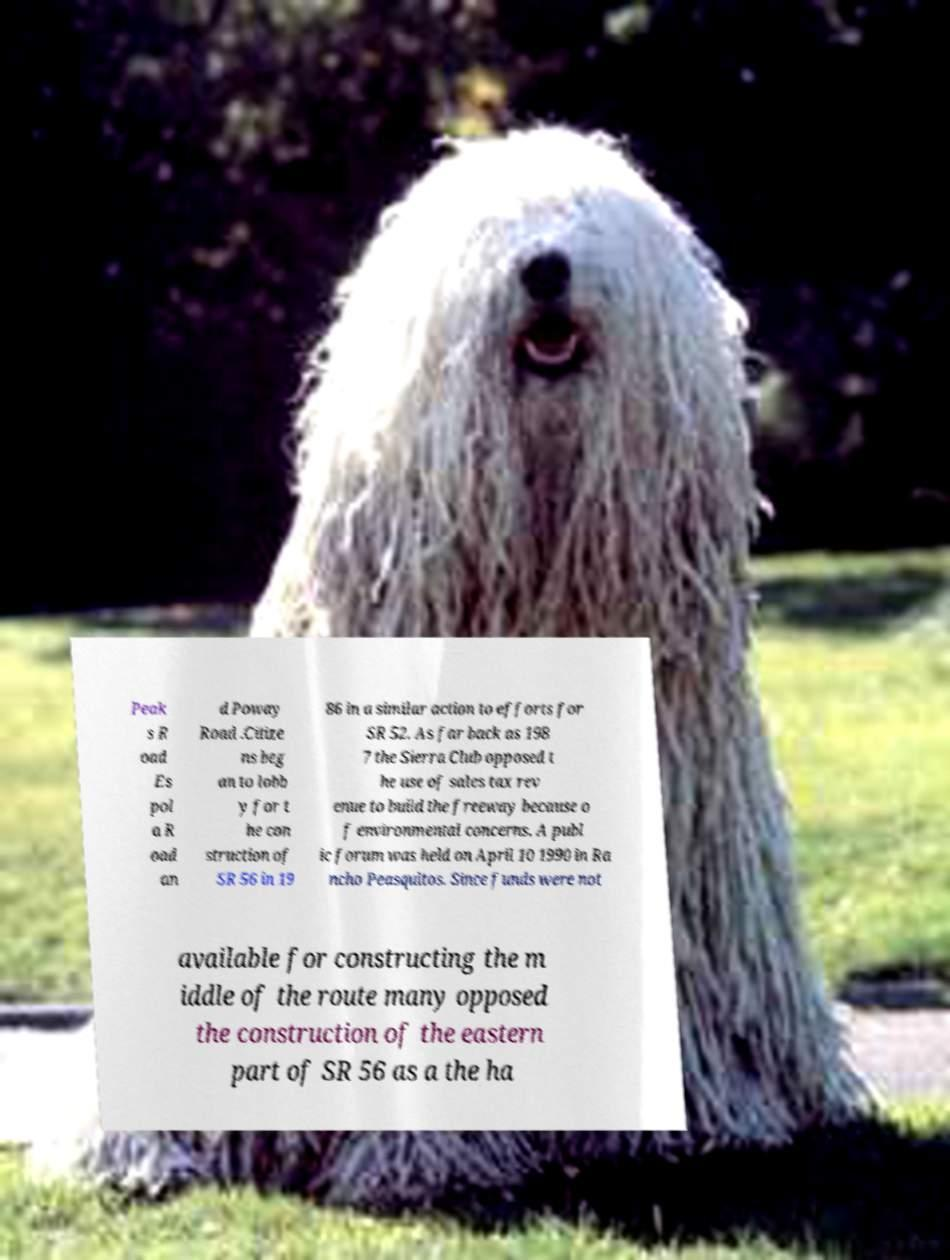Can you read and provide the text displayed in the image?This photo seems to have some interesting text. Can you extract and type it out for me? Peak s R oad Es pol a R oad an d Poway Road .Citize ns beg an to lobb y for t he con struction of SR 56 in 19 86 in a similar action to efforts for SR 52. As far back as 198 7 the Sierra Club opposed t he use of sales tax rev enue to build the freeway because o f environmental concerns. A publ ic forum was held on April 10 1990 in Ra ncho Peasquitos. Since funds were not available for constructing the m iddle of the route many opposed the construction of the eastern part of SR 56 as a the ha 